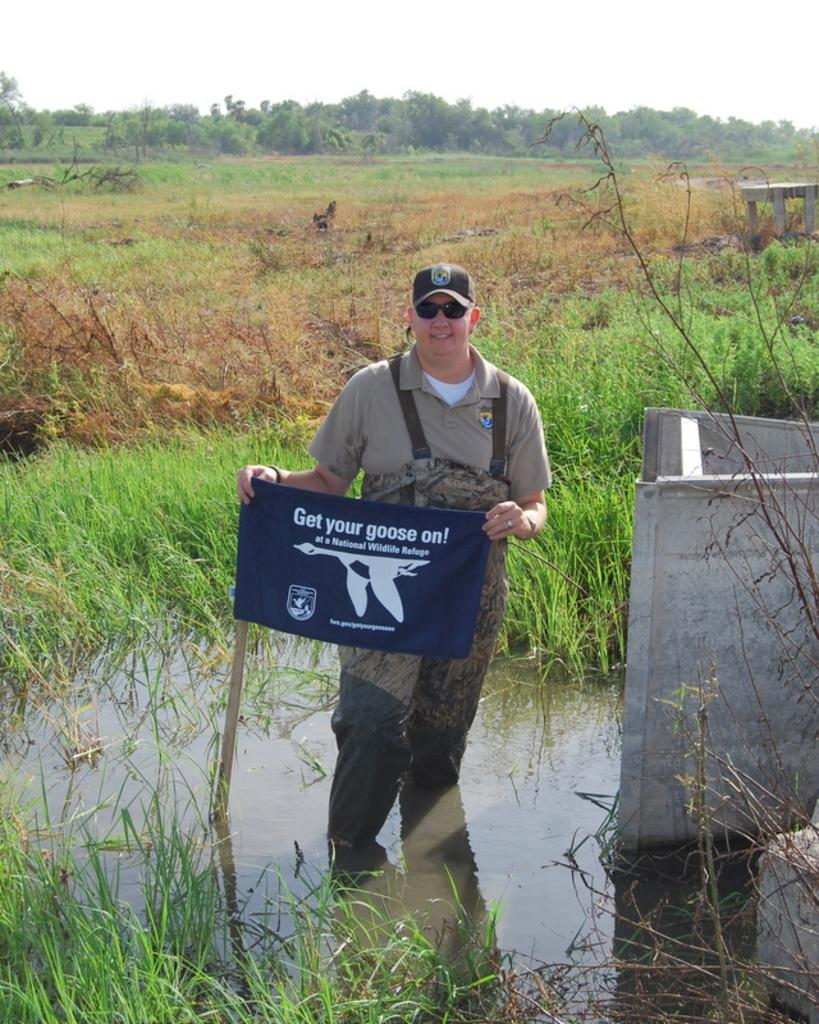Who is present in the image? There is a man in the image. What is the man holding in the image? The man is holding a flag. What can be seen in the background of the image? There are trees in the background of the image. How would you describe the weather in the image? The sky is clear in the image, suggesting good weather. What type of cake is being served at the book reading event in the image? There is no cake or book reading event present in the image. How many books are visible on the hydrant in the image? There is no hydrant or books present in the image. 